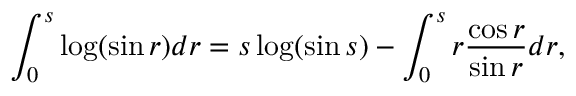Convert formula to latex. <formula><loc_0><loc_0><loc_500><loc_500>\int _ { 0 } ^ { s } \log ( \sin r ) d r = s \log ( \sin s ) - \int _ { 0 } ^ { s } r \frac { \cos r } { \sin r } d r ,</formula> 